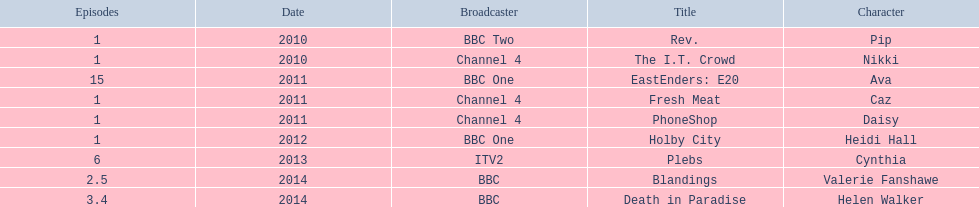What is the only role she played with broadcaster itv2? Cynthia. 